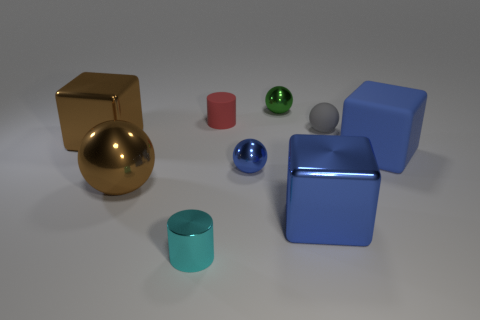How many tiny blue metallic objects are behind the red thing?
Provide a succinct answer. 0. Are there any purple cylinders that have the same size as the gray matte ball?
Provide a short and direct response. No. Are there any shiny cylinders that have the same color as the big sphere?
Your answer should be compact. No. Is there any other thing that has the same size as the brown ball?
Your answer should be very brief. Yes. What number of small shiny spheres are the same color as the big rubber cube?
Offer a very short reply. 1. Is the color of the rubber ball the same as the cylinder that is in front of the large brown shiny block?
Your answer should be compact. No. How many things are big blue objects or rubber things right of the green object?
Provide a short and direct response. 3. How big is the cylinder behind the object to the right of the gray rubber ball?
Offer a terse response. Small. Are there an equal number of balls to the right of the green ball and shiny things on the left side of the tiny cyan cylinder?
Your answer should be very brief. No. There is a big brown object that is in front of the rubber cube; is there a large brown ball that is on the left side of it?
Provide a short and direct response. No. 